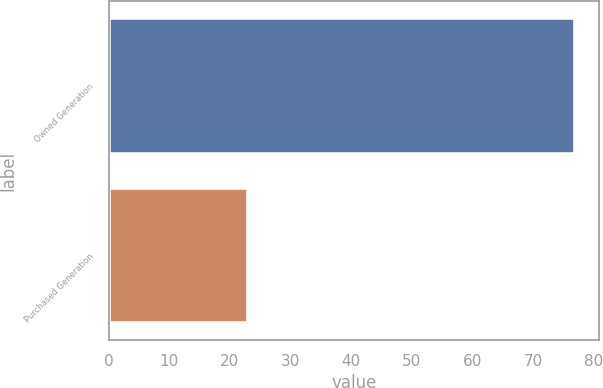<chart> <loc_0><loc_0><loc_500><loc_500><bar_chart><fcel>Owned Generation<fcel>Purchased Generation<nl><fcel>77<fcel>23<nl></chart> 